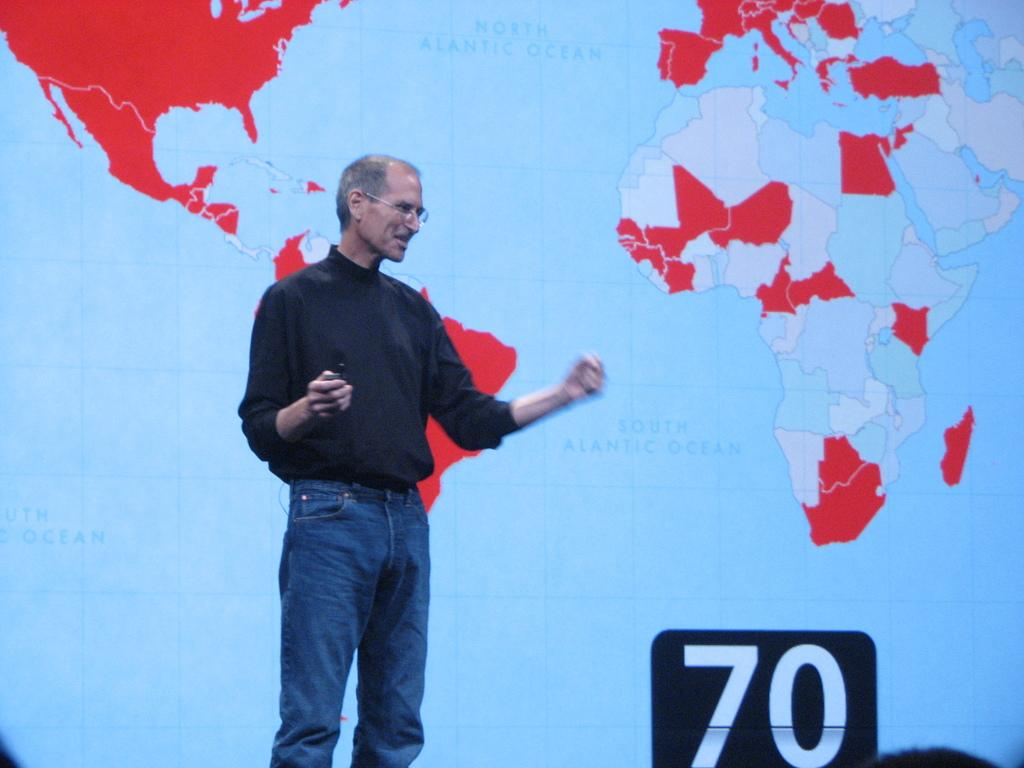What is the person in the image doing? The person is standing in the image. What is the person holding in the image? The person is holding an object. What can be seen in the background of the image? There is a screen with maps in the background of the image. What number is visible on the right side of the image? The number 70 is visible on the right side of the image. What type of plastic is the person biting in the image? There is no plastic or biting action depicted in the image. 